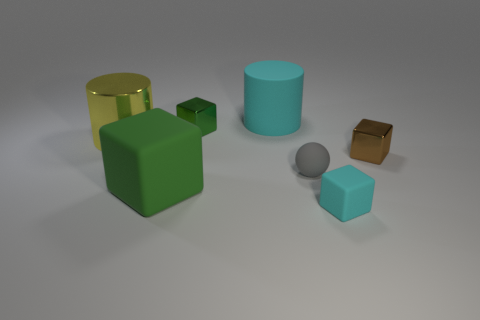Subtract 1 cubes. How many cubes are left? 3 Add 1 small green objects. How many objects exist? 8 Subtract all balls. How many objects are left? 6 Add 5 matte spheres. How many matte spheres are left? 6 Add 2 tiny matte spheres. How many tiny matte spheres exist? 3 Subtract 0 blue cylinders. How many objects are left? 7 Subtract all spheres. Subtract all green spheres. How many objects are left? 6 